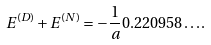Convert formula to latex. <formula><loc_0><loc_0><loc_500><loc_500>E ^ { ( D ) } + E ^ { ( N ) } = - \frac { 1 } { a } 0 . 2 2 0 9 5 8 \dots .</formula> 